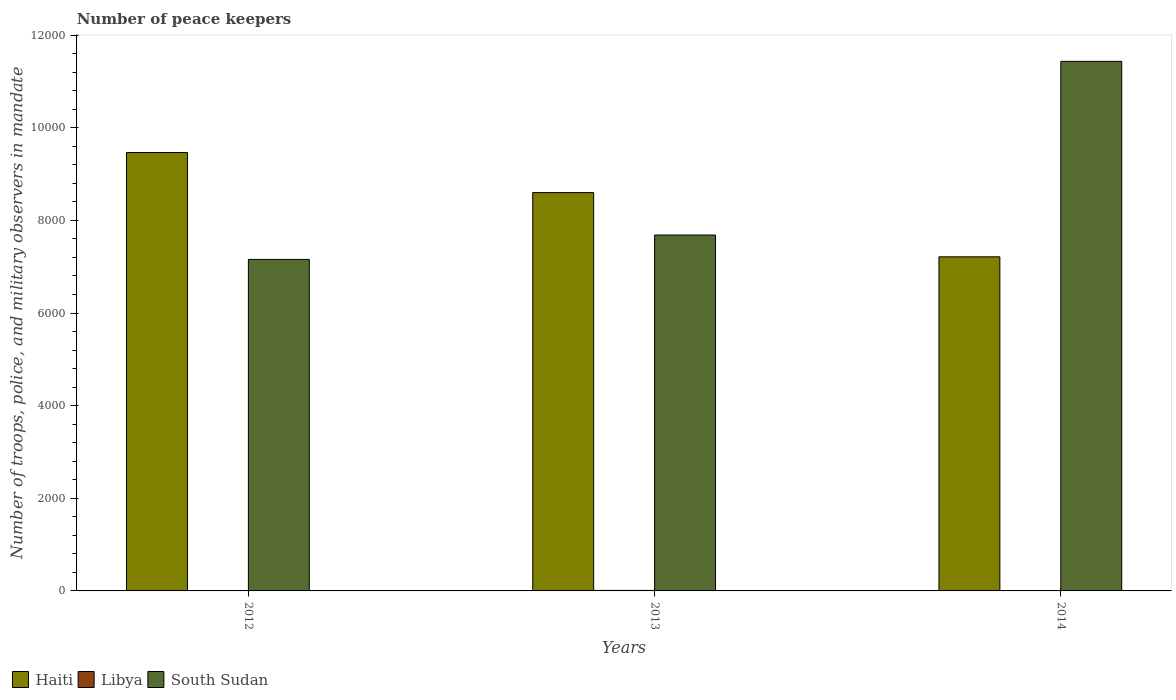How many different coloured bars are there?
Your response must be concise. 3. Are the number of bars on each tick of the X-axis equal?
Your response must be concise. Yes. How many bars are there on the 3rd tick from the right?
Ensure brevity in your answer.  3. What is the label of the 1st group of bars from the left?
Ensure brevity in your answer.  2012. What is the number of peace keepers in in South Sudan in 2012?
Give a very brief answer. 7157. Across all years, what is the maximum number of peace keepers in in South Sudan?
Your answer should be very brief. 1.14e+04. Across all years, what is the minimum number of peace keepers in in South Sudan?
Provide a short and direct response. 7157. What is the total number of peace keepers in in Libya in the graph?
Ensure brevity in your answer.  15. What is the difference between the number of peace keepers in in South Sudan in 2012 and that in 2013?
Your response must be concise. -527. What is the difference between the number of peace keepers in in Haiti in 2012 and the number of peace keepers in in Libya in 2013?
Ensure brevity in your answer.  9453. What is the average number of peace keepers in in Haiti per year?
Provide a short and direct response. 8425.67. In the year 2014, what is the difference between the number of peace keepers in in Haiti and number of peace keepers in in Libya?
Offer a very short reply. 7211. In how many years, is the number of peace keepers in in South Sudan greater than 6800?
Provide a succinct answer. 3. What is the ratio of the number of peace keepers in in South Sudan in 2012 to that in 2014?
Ensure brevity in your answer.  0.63. Is the number of peace keepers in in Haiti in 2012 less than that in 2014?
Provide a succinct answer. No. Is the difference between the number of peace keepers in in Haiti in 2013 and 2014 greater than the difference between the number of peace keepers in in Libya in 2013 and 2014?
Provide a succinct answer. Yes. What is the difference between the highest and the second highest number of peace keepers in in South Sudan?
Give a very brief answer. 3749. What is the difference between the highest and the lowest number of peace keepers in in South Sudan?
Provide a short and direct response. 4276. In how many years, is the number of peace keepers in in South Sudan greater than the average number of peace keepers in in South Sudan taken over all years?
Offer a very short reply. 1. Is the sum of the number of peace keepers in in Libya in 2012 and 2014 greater than the maximum number of peace keepers in in Haiti across all years?
Keep it short and to the point. No. What does the 1st bar from the left in 2014 represents?
Offer a terse response. Haiti. What does the 2nd bar from the right in 2012 represents?
Give a very brief answer. Libya. Is it the case that in every year, the sum of the number of peace keepers in in Haiti and number of peace keepers in in Libya is greater than the number of peace keepers in in South Sudan?
Keep it short and to the point. No. How many bars are there?
Provide a succinct answer. 9. What is the difference between two consecutive major ticks on the Y-axis?
Provide a succinct answer. 2000. Where does the legend appear in the graph?
Offer a very short reply. Bottom left. What is the title of the graph?
Your response must be concise. Number of peace keepers. Does "Liechtenstein" appear as one of the legend labels in the graph?
Your response must be concise. No. What is the label or title of the Y-axis?
Provide a succinct answer. Number of troops, police, and military observers in mandate. What is the Number of troops, police, and military observers in mandate of Haiti in 2012?
Offer a terse response. 9464. What is the Number of troops, police, and military observers in mandate in South Sudan in 2012?
Ensure brevity in your answer.  7157. What is the Number of troops, police, and military observers in mandate in Haiti in 2013?
Your answer should be compact. 8600. What is the Number of troops, police, and military observers in mandate in South Sudan in 2013?
Your answer should be very brief. 7684. What is the Number of troops, police, and military observers in mandate in Haiti in 2014?
Give a very brief answer. 7213. What is the Number of troops, police, and military observers in mandate of South Sudan in 2014?
Provide a succinct answer. 1.14e+04. Across all years, what is the maximum Number of troops, police, and military observers in mandate in Haiti?
Your answer should be compact. 9464. Across all years, what is the maximum Number of troops, police, and military observers in mandate of Libya?
Give a very brief answer. 11. Across all years, what is the maximum Number of troops, police, and military observers in mandate in South Sudan?
Make the answer very short. 1.14e+04. Across all years, what is the minimum Number of troops, police, and military observers in mandate in Haiti?
Keep it short and to the point. 7213. Across all years, what is the minimum Number of troops, police, and military observers in mandate of Libya?
Your response must be concise. 2. Across all years, what is the minimum Number of troops, police, and military observers in mandate of South Sudan?
Ensure brevity in your answer.  7157. What is the total Number of troops, police, and military observers in mandate of Haiti in the graph?
Provide a succinct answer. 2.53e+04. What is the total Number of troops, police, and military observers in mandate of Libya in the graph?
Offer a terse response. 15. What is the total Number of troops, police, and military observers in mandate in South Sudan in the graph?
Make the answer very short. 2.63e+04. What is the difference between the Number of troops, police, and military observers in mandate in Haiti in 2012 and that in 2013?
Your response must be concise. 864. What is the difference between the Number of troops, police, and military observers in mandate of Libya in 2012 and that in 2013?
Provide a succinct answer. -9. What is the difference between the Number of troops, police, and military observers in mandate of South Sudan in 2012 and that in 2013?
Offer a terse response. -527. What is the difference between the Number of troops, police, and military observers in mandate of Haiti in 2012 and that in 2014?
Offer a very short reply. 2251. What is the difference between the Number of troops, police, and military observers in mandate in Libya in 2012 and that in 2014?
Make the answer very short. 0. What is the difference between the Number of troops, police, and military observers in mandate in South Sudan in 2012 and that in 2014?
Your response must be concise. -4276. What is the difference between the Number of troops, police, and military observers in mandate in Haiti in 2013 and that in 2014?
Provide a short and direct response. 1387. What is the difference between the Number of troops, police, and military observers in mandate in Libya in 2013 and that in 2014?
Your answer should be very brief. 9. What is the difference between the Number of troops, police, and military observers in mandate in South Sudan in 2013 and that in 2014?
Offer a very short reply. -3749. What is the difference between the Number of troops, police, and military observers in mandate of Haiti in 2012 and the Number of troops, police, and military observers in mandate of Libya in 2013?
Provide a short and direct response. 9453. What is the difference between the Number of troops, police, and military observers in mandate of Haiti in 2012 and the Number of troops, police, and military observers in mandate of South Sudan in 2013?
Your answer should be compact. 1780. What is the difference between the Number of troops, police, and military observers in mandate of Libya in 2012 and the Number of troops, police, and military observers in mandate of South Sudan in 2013?
Provide a short and direct response. -7682. What is the difference between the Number of troops, police, and military observers in mandate of Haiti in 2012 and the Number of troops, police, and military observers in mandate of Libya in 2014?
Ensure brevity in your answer.  9462. What is the difference between the Number of troops, police, and military observers in mandate in Haiti in 2012 and the Number of troops, police, and military observers in mandate in South Sudan in 2014?
Ensure brevity in your answer.  -1969. What is the difference between the Number of troops, police, and military observers in mandate in Libya in 2012 and the Number of troops, police, and military observers in mandate in South Sudan in 2014?
Your answer should be very brief. -1.14e+04. What is the difference between the Number of troops, police, and military observers in mandate in Haiti in 2013 and the Number of troops, police, and military observers in mandate in Libya in 2014?
Your answer should be compact. 8598. What is the difference between the Number of troops, police, and military observers in mandate of Haiti in 2013 and the Number of troops, police, and military observers in mandate of South Sudan in 2014?
Your response must be concise. -2833. What is the difference between the Number of troops, police, and military observers in mandate of Libya in 2013 and the Number of troops, police, and military observers in mandate of South Sudan in 2014?
Offer a very short reply. -1.14e+04. What is the average Number of troops, police, and military observers in mandate in Haiti per year?
Offer a very short reply. 8425.67. What is the average Number of troops, police, and military observers in mandate of Libya per year?
Offer a terse response. 5. What is the average Number of troops, police, and military observers in mandate of South Sudan per year?
Your answer should be very brief. 8758. In the year 2012, what is the difference between the Number of troops, police, and military observers in mandate in Haiti and Number of troops, police, and military observers in mandate in Libya?
Offer a very short reply. 9462. In the year 2012, what is the difference between the Number of troops, police, and military observers in mandate in Haiti and Number of troops, police, and military observers in mandate in South Sudan?
Give a very brief answer. 2307. In the year 2012, what is the difference between the Number of troops, police, and military observers in mandate of Libya and Number of troops, police, and military observers in mandate of South Sudan?
Your answer should be compact. -7155. In the year 2013, what is the difference between the Number of troops, police, and military observers in mandate of Haiti and Number of troops, police, and military observers in mandate of Libya?
Offer a terse response. 8589. In the year 2013, what is the difference between the Number of troops, police, and military observers in mandate of Haiti and Number of troops, police, and military observers in mandate of South Sudan?
Offer a terse response. 916. In the year 2013, what is the difference between the Number of troops, police, and military observers in mandate of Libya and Number of troops, police, and military observers in mandate of South Sudan?
Provide a succinct answer. -7673. In the year 2014, what is the difference between the Number of troops, police, and military observers in mandate of Haiti and Number of troops, police, and military observers in mandate of Libya?
Make the answer very short. 7211. In the year 2014, what is the difference between the Number of troops, police, and military observers in mandate in Haiti and Number of troops, police, and military observers in mandate in South Sudan?
Your answer should be compact. -4220. In the year 2014, what is the difference between the Number of troops, police, and military observers in mandate of Libya and Number of troops, police, and military observers in mandate of South Sudan?
Keep it short and to the point. -1.14e+04. What is the ratio of the Number of troops, police, and military observers in mandate in Haiti in 2012 to that in 2013?
Offer a very short reply. 1.1. What is the ratio of the Number of troops, police, and military observers in mandate of Libya in 2012 to that in 2013?
Offer a terse response. 0.18. What is the ratio of the Number of troops, police, and military observers in mandate in South Sudan in 2012 to that in 2013?
Offer a terse response. 0.93. What is the ratio of the Number of troops, police, and military observers in mandate in Haiti in 2012 to that in 2014?
Provide a succinct answer. 1.31. What is the ratio of the Number of troops, police, and military observers in mandate in South Sudan in 2012 to that in 2014?
Your response must be concise. 0.63. What is the ratio of the Number of troops, police, and military observers in mandate in Haiti in 2013 to that in 2014?
Keep it short and to the point. 1.19. What is the ratio of the Number of troops, police, and military observers in mandate in Libya in 2013 to that in 2014?
Your answer should be compact. 5.5. What is the ratio of the Number of troops, police, and military observers in mandate in South Sudan in 2013 to that in 2014?
Ensure brevity in your answer.  0.67. What is the difference between the highest and the second highest Number of troops, police, and military observers in mandate of Haiti?
Your answer should be very brief. 864. What is the difference between the highest and the second highest Number of troops, police, and military observers in mandate of South Sudan?
Keep it short and to the point. 3749. What is the difference between the highest and the lowest Number of troops, police, and military observers in mandate in Haiti?
Your answer should be compact. 2251. What is the difference between the highest and the lowest Number of troops, police, and military observers in mandate in Libya?
Provide a succinct answer. 9. What is the difference between the highest and the lowest Number of troops, police, and military observers in mandate in South Sudan?
Provide a short and direct response. 4276. 